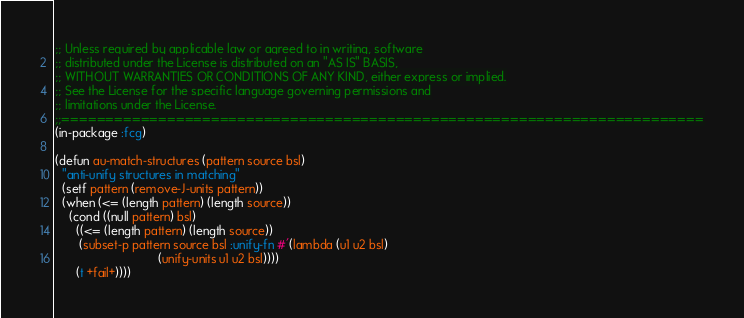<code> <loc_0><loc_0><loc_500><loc_500><_Lisp_>;; Unless required by applicable law or agreed to in writing, software
;; distributed under the License is distributed on an "AS IS" BASIS,
;; WITHOUT WARRANTIES OR CONDITIONS OF ANY KIND, either express or implied.
;; See the License for the specific language governing permissions and
;; limitations under the License.
;;=========================================================================
(in-package :fcg)

(defun au-match-structures (pattern source bsl)
  "anti-unify structures in matching"
  (setf pattern (remove-J-units pattern))
  (when (<= (length pattern) (length source))
    (cond ((null pattern) bsl)
	  ((<= (length pattern) (length source))
	   (subset-p pattern source bsl :unify-fn #'(lambda (u1 u2 bsl)
						      (unify-units u1 u2 bsl))))
	  (t +fail+))))</code> 